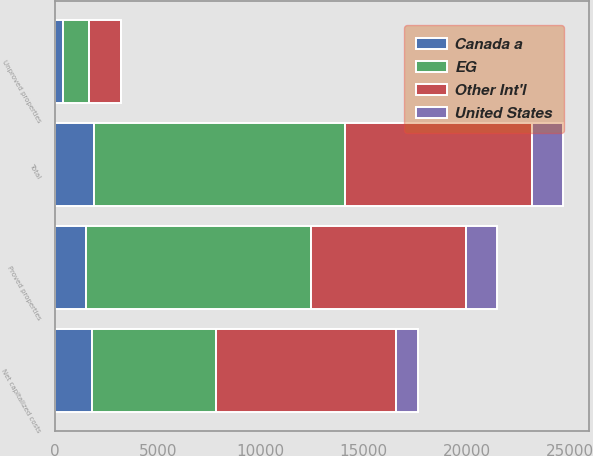Convert chart to OTSL. <chart><loc_0><loc_0><loc_500><loc_500><stacked_bar_chart><ecel><fcel>Proved properties<fcel>Unproved properties<fcel>Total<fcel>Net capitalized costs<nl><fcel>EG<fcel>10927<fcel>1258<fcel>12185<fcel>5997<nl><fcel>Other Int'l<fcel>7510<fcel>1544<fcel>9054<fcel>8774<nl><fcel>United States<fcel>1521<fcel>24<fcel>1545<fcel>1029<nl><fcel>Canada a<fcel>1505<fcel>404<fcel>1909<fcel>1815<nl></chart> 